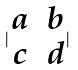Convert formula to latex. <formula><loc_0><loc_0><loc_500><loc_500>| \begin{matrix} a & b \\ c & d \end{matrix} |</formula> 